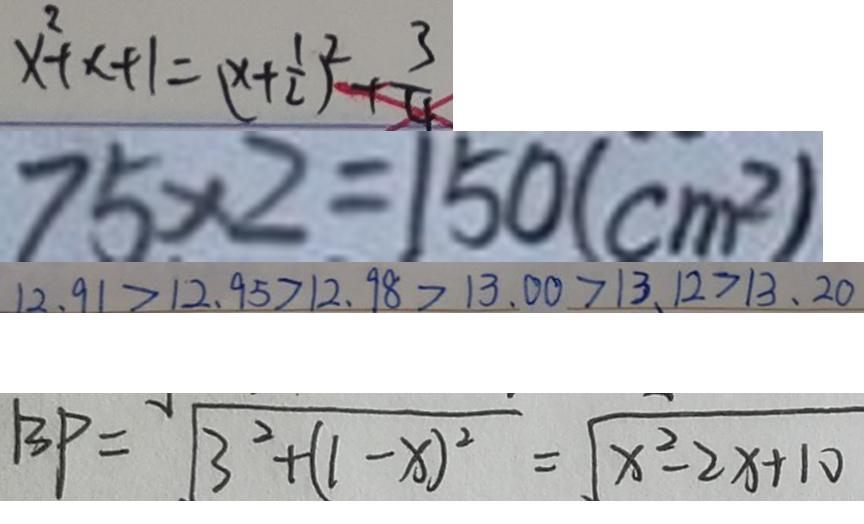Convert formula to latex. <formula><loc_0><loc_0><loc_500><loc_500>x ^ { 2 } + x + 1 = ( x + \frac { 1 } { 2 } ) ^ { 2 } + \frac { 3 } { 4 } 
 7 5 \times 2 = 1 5 0 ( c m ^ { 2 } ) 
 1 2 . 9 1 > 1 2 . 9 5 > 1 2 . 9 8 > 1 3 . 0 0 > 1 3 . 1 2 > 1 3 . 2 0 
 B P = \sqrt { 3 ^ { 2 } + ( 1 - x ) ^ { 2 } } = \sqrt { x ^ { 2 } - 2 x + 1 0 }</formula> 